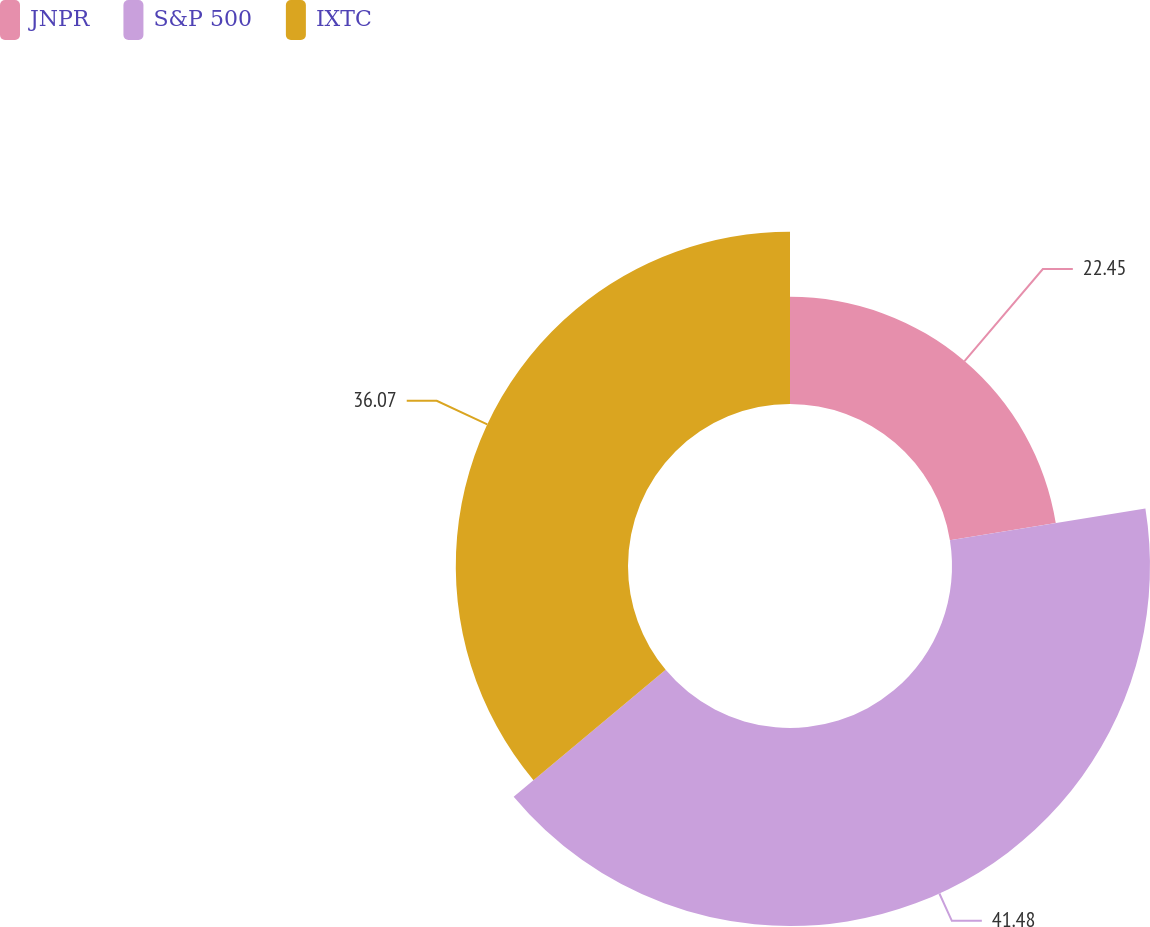Convert chart to OTSL. <chart><loc_0><loc_0><loc_500><loc_500><pie_chart><fcel>JNPR<fcel>S&P 500<fcel>IXTC<nl><fcel>22.45%<fcel>41.47%<fcel>36.07%<nl></chart> 